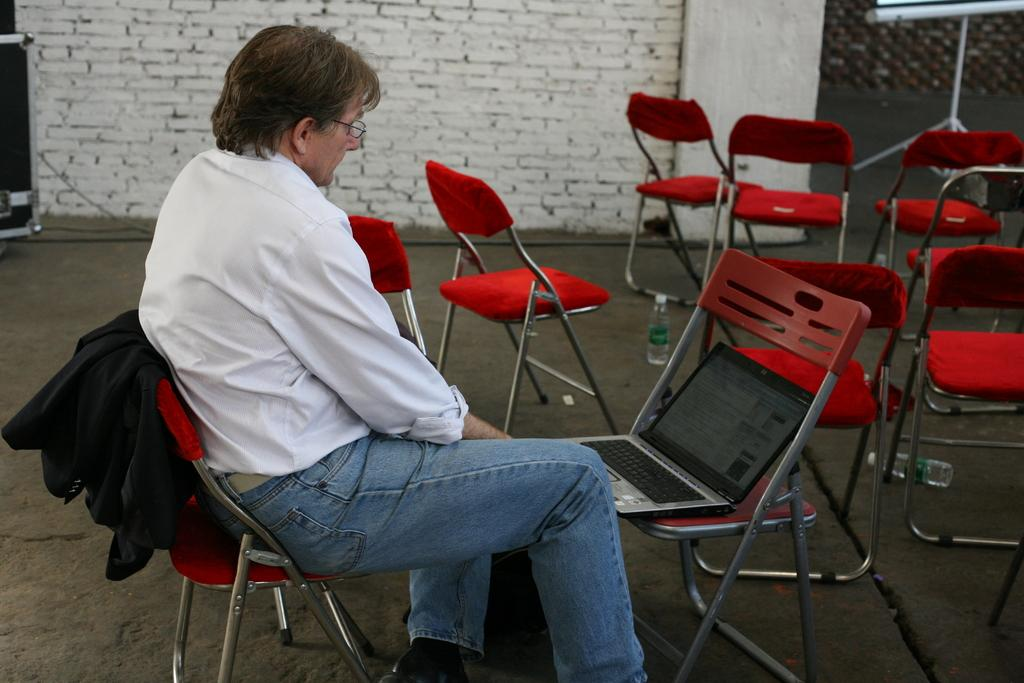What is the person in the image doing? The person is sitting on a chair. How many chairs are visible in the image? There are chairs in the image. What is on the chair that the person is sitting on? There is a cloth and a laptop on the chair. What part of the room can be seen in the image? The floor is visible in the image. What object can be seen near the person? There is a bottle in the image. What is the background of the image? There is a wall in the image. What type of furniture is present in the image? There is a stand in the image. What type of cork can be seen in the image? There is no cork present in the image. What section of the library is shown in the image? The image does not depict a library; it is a person sitting on a chair with various objects around them. 